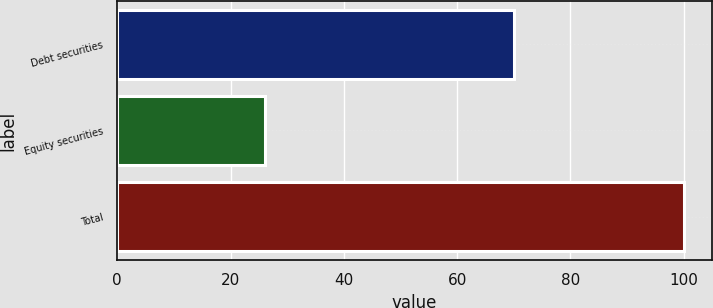<chart> <loc_0><loc_0><loc_500><loc_500><bar_chart><fcel>Debt securities<fcel>Equity securities<fcel>Total<nl><fcel>70<fcel>26<fcel>100<nl></chart> 